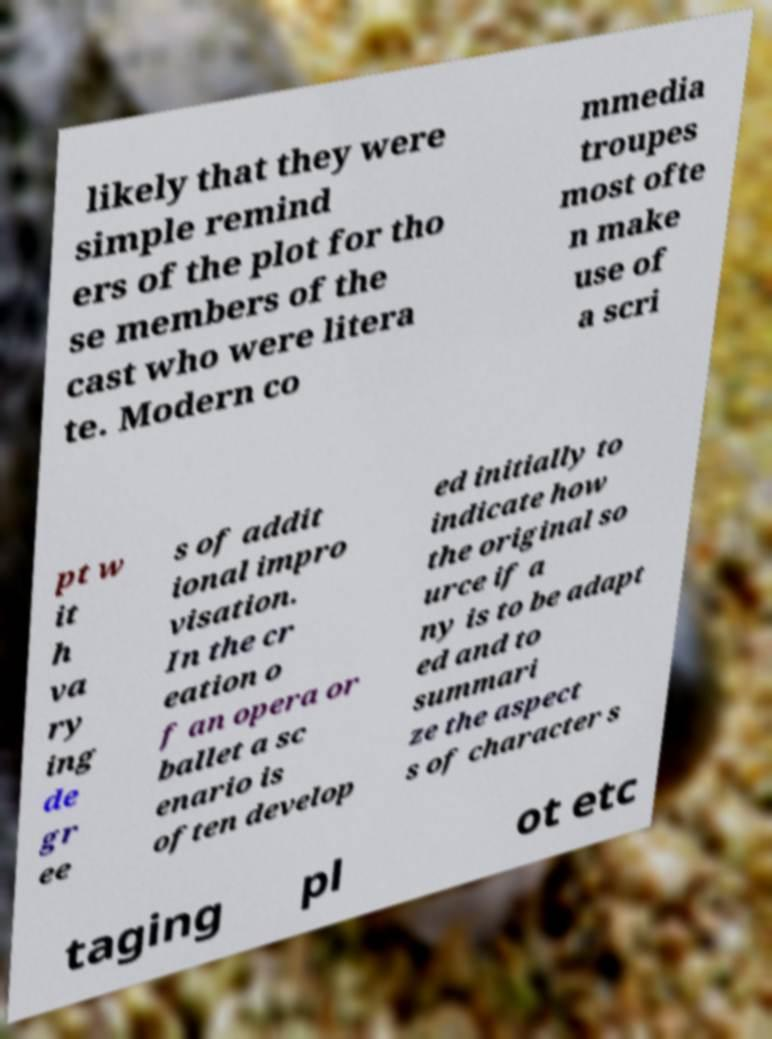Could you assist in decoding the text presented in this image and type it out clearly? likely that they were simple remind ers of the plot for tho se members of the cast who were litera te. Modern co mmedia troupes most ofte n make use of a scri pt w it h va ry ing de gr ee s of addit ional impro visation. In the cr eation o f an opera or ballet a sc enario is often develop ed initially to indicate how the original so urce if a ny is to be adapt ed and to summari ze the aspect s of character s taging pl ot etc 